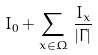<formula> <loc_0><loc_0><loc_500><loc_500>I _ { 0 } + \sum _ { x \in \Omega } \, \frac { I _ { x } } { | \Gamma | }</formula> 